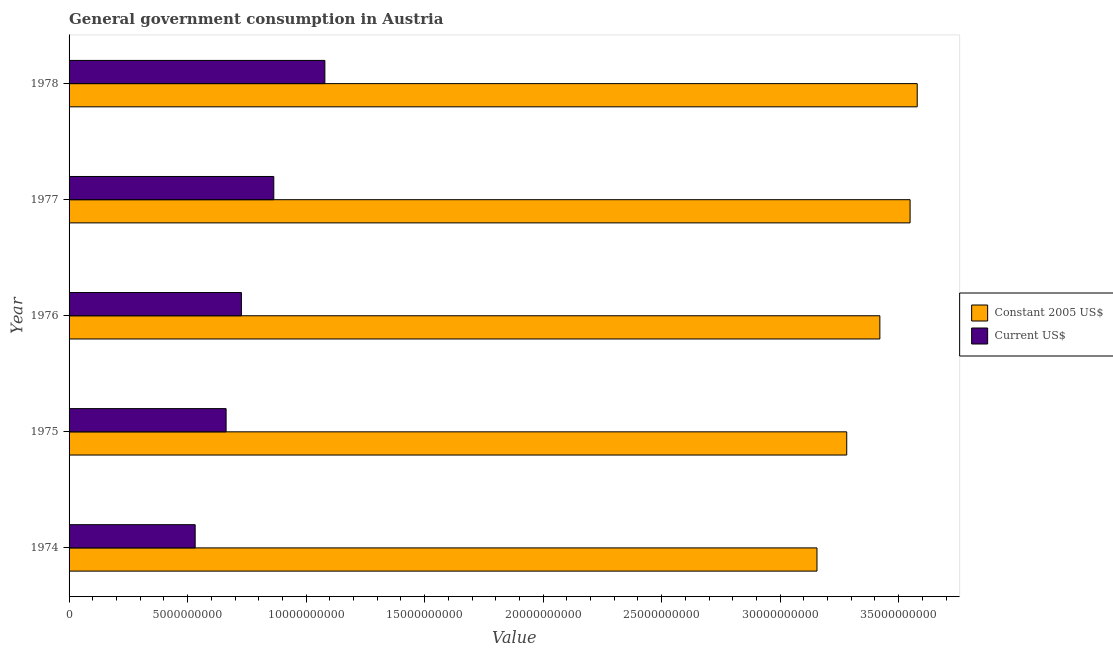How many different coloured bars are there?
Give a very brief answer. 2. Are the number of bars per tick equal to the number of legend labels?
Offer a terse response. Yes. Are the number of bars on each tick of the Y-axis equal?
Give a very brief answer. Yes. How many bars are there on the 4th tick from the top?
Keep it short and to the point. 2. How many bars are there on the 2nd tick from the bottom?
Offer a very short reply. 2. What is the label of the 3rd group of bars from the top?
Offer a terse response. 1976. What is the value consumed in constant 2005 us$ in 1977?
Offer a very short reply. 3.55e+1. Across all years, what is the maximum value consumed in current us$?
Give a very brief answer. 1.08e+1. Across all years, what is the minimum value consumed in current us$?
Keep it short and to the point. 5.32e+09. In which year was the value consumed in constant 2005 us$ maximum?
Provide a short and direct response. 1978. In which year was the value consumed in constant 2005 us$ minimum?
Keep it short and to the point. 1974. What is the total value consumed in constant 2005 us$ in the graph?
Offer a very short reply. 1.70e+11. What is the difference between the value consumed in constant 2005 us$ in 1974 and that in 1977?
Offer a terse response. -3.93e+09. What is the difference between the value consumed in constant 2005 us$ in 1976 and the value consumed in current us$ in 1978?
Make the answer very short. 2.34e+1. What is the average value consumed in constant 2005 us$ per year?
Provide a succinct answer. 3.40e+1. In the year 1974, what is the difference between the value consumed in current us$ and value consumed in constant 2005 us$?
Make the answer very short. -2.62e+1. In how many years, is the value consumed in current us$ greater than 14000000000 ?
Your answer should be very brief. 0. Is the value consumed in constant 2005 us$ in 1974 less than that in 1977?
Provide a short and direct response. Yes. Is the difference between the value consumed in constant 2005 us$ in 1977 and 1978 greater than the difference between the value consumed in current us$ in 1977 and 1978?
Keep it short and to the point. Yes. What is the difference between the highest and the second highest value consumed in constant 2005 us$?
Your response must be concise. 3.01e+08. What is the difference between the highest and the lowest value consumed in constant 2005 us$?
Make the answer very short. 4.23e+09. In how many years, is the value consumed in current us$ greater than the average value consumed in current us$ taken over all years?
Ensure brevity in your answer.  2. What does the 1st bar from the top in 1975 represents?
Your answer should be very brief. Current US$. What does the 2nd bar from the bottom in 1974 represents?
Provide a short and direct response. Current US$. How many bars are there?
Your response must be concise. 10. How many years are there in the graph?
Keep it short and to the point. 5. What is the difference between two consecutive major ticks on the X-axis?
Keep it short and to the point. 5.00e+09. Are the values on the major ticks of X-axis written in scientific E-notation?
Make the answer very short. No. Does the graph contain grids?
Offer a terse response. No. Where does the legend appear in the graph?
Give a very brief answer. Center right. How many legend labels are there?
Your response must be concise. 2. How are the legend labels stacked?
Your response must be concise. Vertical. What is the title of the graph?
Offer a terse response. General government consumption in Austria. Does "US$" appear as one of the legend labels in the graph?
Offer a terse response. No. What is the label or title of the X-axis?
Make the answer very short. Value. What is the Value of Constant 2005 US$ in 1974?
Your response must be concise. 3.16e+1. What is the Value in Current US$ in 1974?
Offer a very short reply. 5.32e+09. What is the Value of Constant 2005 US$ in 1975?
Offer a very short reply. 3.28e+1. What is the Value in Current US$ in 1975?
Your answer should be very brief. 6.63e+09. What is the Value of Constant 2005 US$ in 1976?
Give a very brief answer. 3.42e+1. What is the Value of Current US$ in 1976?
Your answer should be compact. 7.27e+09. What is the Value in Constant 2005 US$ in 1977?
Keep it short and to the point. 3.55e+1. What is the Value in Current US$ in 1977?
Keep it short and to the point. 8.64e+09. What is the Value in Constant 2005 US$ in 1978?
Offer a very short reply. 3.58e+1. What is the Value in Current US$ in 1978?
Ensure brevity in your answer.  1.08e+1. Across all years, what is the maximum Value in Constant 2005 US$?
Your answer should be compact. 3.58e+1. Across all years, what is the maximum Value in Current US$?
Your response must be concise. 1.08e+1. Across all years, what is the minimum Value in Constant 2005 US$?
Ensure brevity in your answer.  3.16e+1. Across all years, what is the minimum Value of Current US$?
Ensure brevity in your answer.  5.32e+09. What is the total Value in Constant 2005 US$ in the graph?
Make the answer very short. 1.70e+11. What is the total Value of Current US$ in the graph?
Your answer should be very brief. 3.86e+1. What is the difference between the Value of Constant 2005 US$ in 1974 and that in 1975?
Your answer should be very brief. -1.26e+09. What is the difference between the Value in Current US$ in 1974 and that in 1975?
Provide a short and direct response. -1.31e+09. What is the difference between the Value of Constant 2005 US$ in 1974 and that in 1976?
Your answer should be compact. -2.65e+09. What is the difference between the Value of Current US$ in 1974 and that in 1976?
Offer a very short reply. -1.95e+09. What is the difference between the Value of Constant 2005 US$ in 1974 and that in 1977?
Your answer should be compact. -3.93e+09. What is the difference between the Value in Current US$ in 1974 and that in 1977?
Your response must be concise. -3.32e+09. What is the difference between the Value of Constant 2005 US$ in 1974 and that in 1978?
Provide a succinct answer. -4.23e+09. What is the difference between the Value of Current US$ in 1974 and that in 1978?
Your answer should be compact. -5.47e+09. What is the difference between the Value in Constant 2005 US$ in 1975 and that in 1976?
Offer a terse response. -1.40e+09. What is the difference between the Value in Current US$ in 1975 and that in 1976?
Make the answer very short. -6.46e+08. What is the difference between the Value of Constant 2005 US$ in 1975 and that in 1977?
Provide a short and direct response. -2.67e+09. What is the difference between the Value of Current US$ in 1975 and that in 1977?
Ensure brevity in your answer.  -2.01e+09. What is the difference between the Value of Constant 2005 US$ in 1975 and that in 1978?
Provide a short and direct response. -2.97e+09. What is the difference between the Value of Current US$ in 1975 and that in 1978?
Ensure brevity in your answer.  -4.17e+09. What is the difference between the Value in Constant 2005 US$ in 1976 and that in 1977?
Provide a short and direct response. -1.28e+09. What is the difference between the Value of Current US$ in 1976 and that in 1977?
Provide a succinct answer. -1.37e+09. What is the difference between the Value in Constant 2005 US$ in 1976 and that in 1978?
Give a very brief answer. -1.58e+09. What is the difference between the Value of Current US$ in 1976 and that in 1978?
Make the answer very short. -3.52e+09. What is the difference between the Value in Constant 2005 US$ in 1977 and that in 1978?
Provide a succinct answer. -3.01e+08. What is the difference between the Value in Current US$ in 1977 and that in 1978?
Your response must be concise. -2.15e+09. What is the difference between the Value of Constant 2005 US$ in 1974 and the Value of Current US$ in 1975?
Your answer should be compact. 2.49e+1. What is the difference between the Value in Constant 2005 US$ in 1974 and the Value in Current US$ in 1976?
Your answer should be compact. 2.43e+1. What is the difference between the Value of Constant 2005 US$ in 1974 and the Value of Current US$ in 1977?
Keep it short and to the point. 2.29e+1. What is the difference between the Value in Constant 2005 US$ in 1974 and the Value in Current US$ in 1978?
Ensure brevity in your answer.  2.08e+1. What is the difference between the Value of Constant 2005 US$ in 1975 and the Value of Current US$ in 1976?
Your response must be concise. 2.55e+1. What is the difference between the Value in Constant 2005 US$ in 1975 and the Value in Current US$ in 1977?
Your answer should be compact. 2.42e+1. What is the difference between the Value of Constant 2005 US$ in 1975 and the Value of Current US$ in 1978?
Your answer should be compact. 2.20e+1. What is the difference between the Value of Constant 2005 US$ in 1976 and the Value of Current US$ in 1977?
Offer a very short reply. 2.56e+1. What is the difference between the Value in Constant 2005 US$ in 1976 and the Value in Current US$ in 1978?
Keep it short and to the point. 2.34e+1. What is the difference between the Value of Constant 2005 US$ in 1977 and the Value of Current US$ in 1978?
Your answer should be compact. 2.47e+1. What is the average Value in Constant 2005 US$ per year?
Offer a terse response. 3.40e+1. What is the average Value of Current US$ per year?
Your response must be concise. 7.73e+09. In the year 1974, what is the difference between the Value of Constant 2005 US$ and Value of Current US$?
Offer a very short reply. 2.62e+1. In the year 1975, what is the difference between the Value in Constant 2005 US$ and Value in Current US$?
Ensure brevity in your answer.  2.62e+1. In the year 1976, what is the difference between the Value in Constant 2005 US$ and Value in Current US$?
Your answer should be compact. 2.69e+1. In the year 1977, what is the difference between the Value in Constant 2005 US$ and Value in Current US$?
Your answer should be very brief. 2.68e+1. In the year 1978, what is the difference between the Value in Constant 2005 US$ and Value in Current US$?
Your response must be concise. 2.50e+1. What is the ratio of the Value in Constant 2005 US$ in 1974 to that in 1975?
Provide a succinct answer. 0.96. What is the ratio of the Value of Current US$ in 1974 to that in 1975?
Provide a short and direct response. 0.8. What is the ratio of the Value of Constant 2005 US$ in 1974 to that in 1976?
Give a very brief answer. 0.92. What is the ratio of the Value of Current US$ in 1974 to that in 1976?
Your answer should be compact. 0.73. What is the ratio of the Value in Constant 2005 US$ in 1974 to that in 1977?
Your response must be concise. 0.89. What is the ratio of the Value of Current US$ in 1974 to that in 1977?
Offer a very short reply. 0.62. What is the ratio of the Value of Constant 2005 US$ in 1974 to that in 1978?
Ensure brevity in your answer.  0.88. What is the ratio of the Value of Current US$ in 1974 to that in 1978?
Your response must be concise. 0.49. What is the ratio of the Value of Constant 2005 US$ in 1975 to that in 1976?
Give a very brief answer. 0.96. What is the ratio of the Value of Current US$ in 1975 to that in 1976?
Your answer should be very brief. 0.91. What is the ratio of the Value in Constant 2005 US$ in 1975 to that in 1977?
Offer a very short reply. 0.92. What is the ratio of the Value of Current US$ in 1975 to that in 1977?
Your answer should be compact. 0.77. What is the ratio of the Value in Constant 2005 US$ in 1975 to that in 1978?
Your response must be concise. 0.92. What is the ratio of the Value in Current US$ in 1975 to that in 1978?
Give a very brief answer. 0.61. What is the ratio of the Value in Constant 2005 US$ in 1976 to that in 1977?
Your answer should be very brief. 0.96. What is the ratio of the Value of Current US$ in 1976 to that in 1977?
Offer a terse response. 0.84. What is the ratio of the Value in Constant 2005 US$ in 1976 to that in 1978?
Your answer should be very brief. 0.96. What is the ratio of the Value of Current US$ in 1976 to that in 1978?
Ensure brevity in your answer.  0.67. What is the ratio of the Value of Current US$ in 1977 to that in 1978?
Your answer should be compact. 0.8. What is the difference between the highest and the second highest Value in Constant 2005 US$?
Keep it short and to the point. 3.01e+08. What is the difference between the highest and the second highest Value in Current US$?
Give a very brief answer. 2.15e+09. What is the difference between the highest and the lowest Value in Constant 2005 US$?
Keep it short and to the point. 4.23e+09. What is the difference between the highest and the lowest Value of Current US$?
Your answer should be very brief. 5.47e+09. 